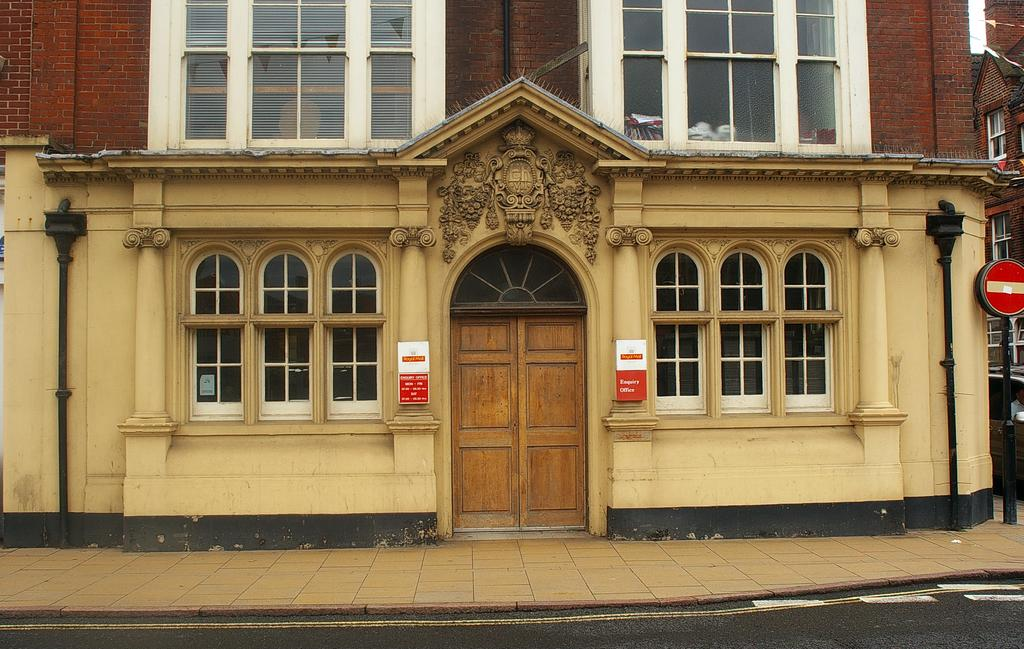What type of structure is present in the image? There is a building in the image. What features can be seen on the building? The building has windows and doors. What additional objects are visible in the image? There are pipes, boards on the wall, and a pole visible in the image. What can be seen on the right side of the image? On the right side of the image, there are buildings, windows, and a pole. What part of the natural environment is visible in the image? The sky is visible in the image. What type of wound can be seen on the building in the image? There is no wound present on the building in the image. What type of cable is connected to the pole in the image? There is no cable visible in the image. 